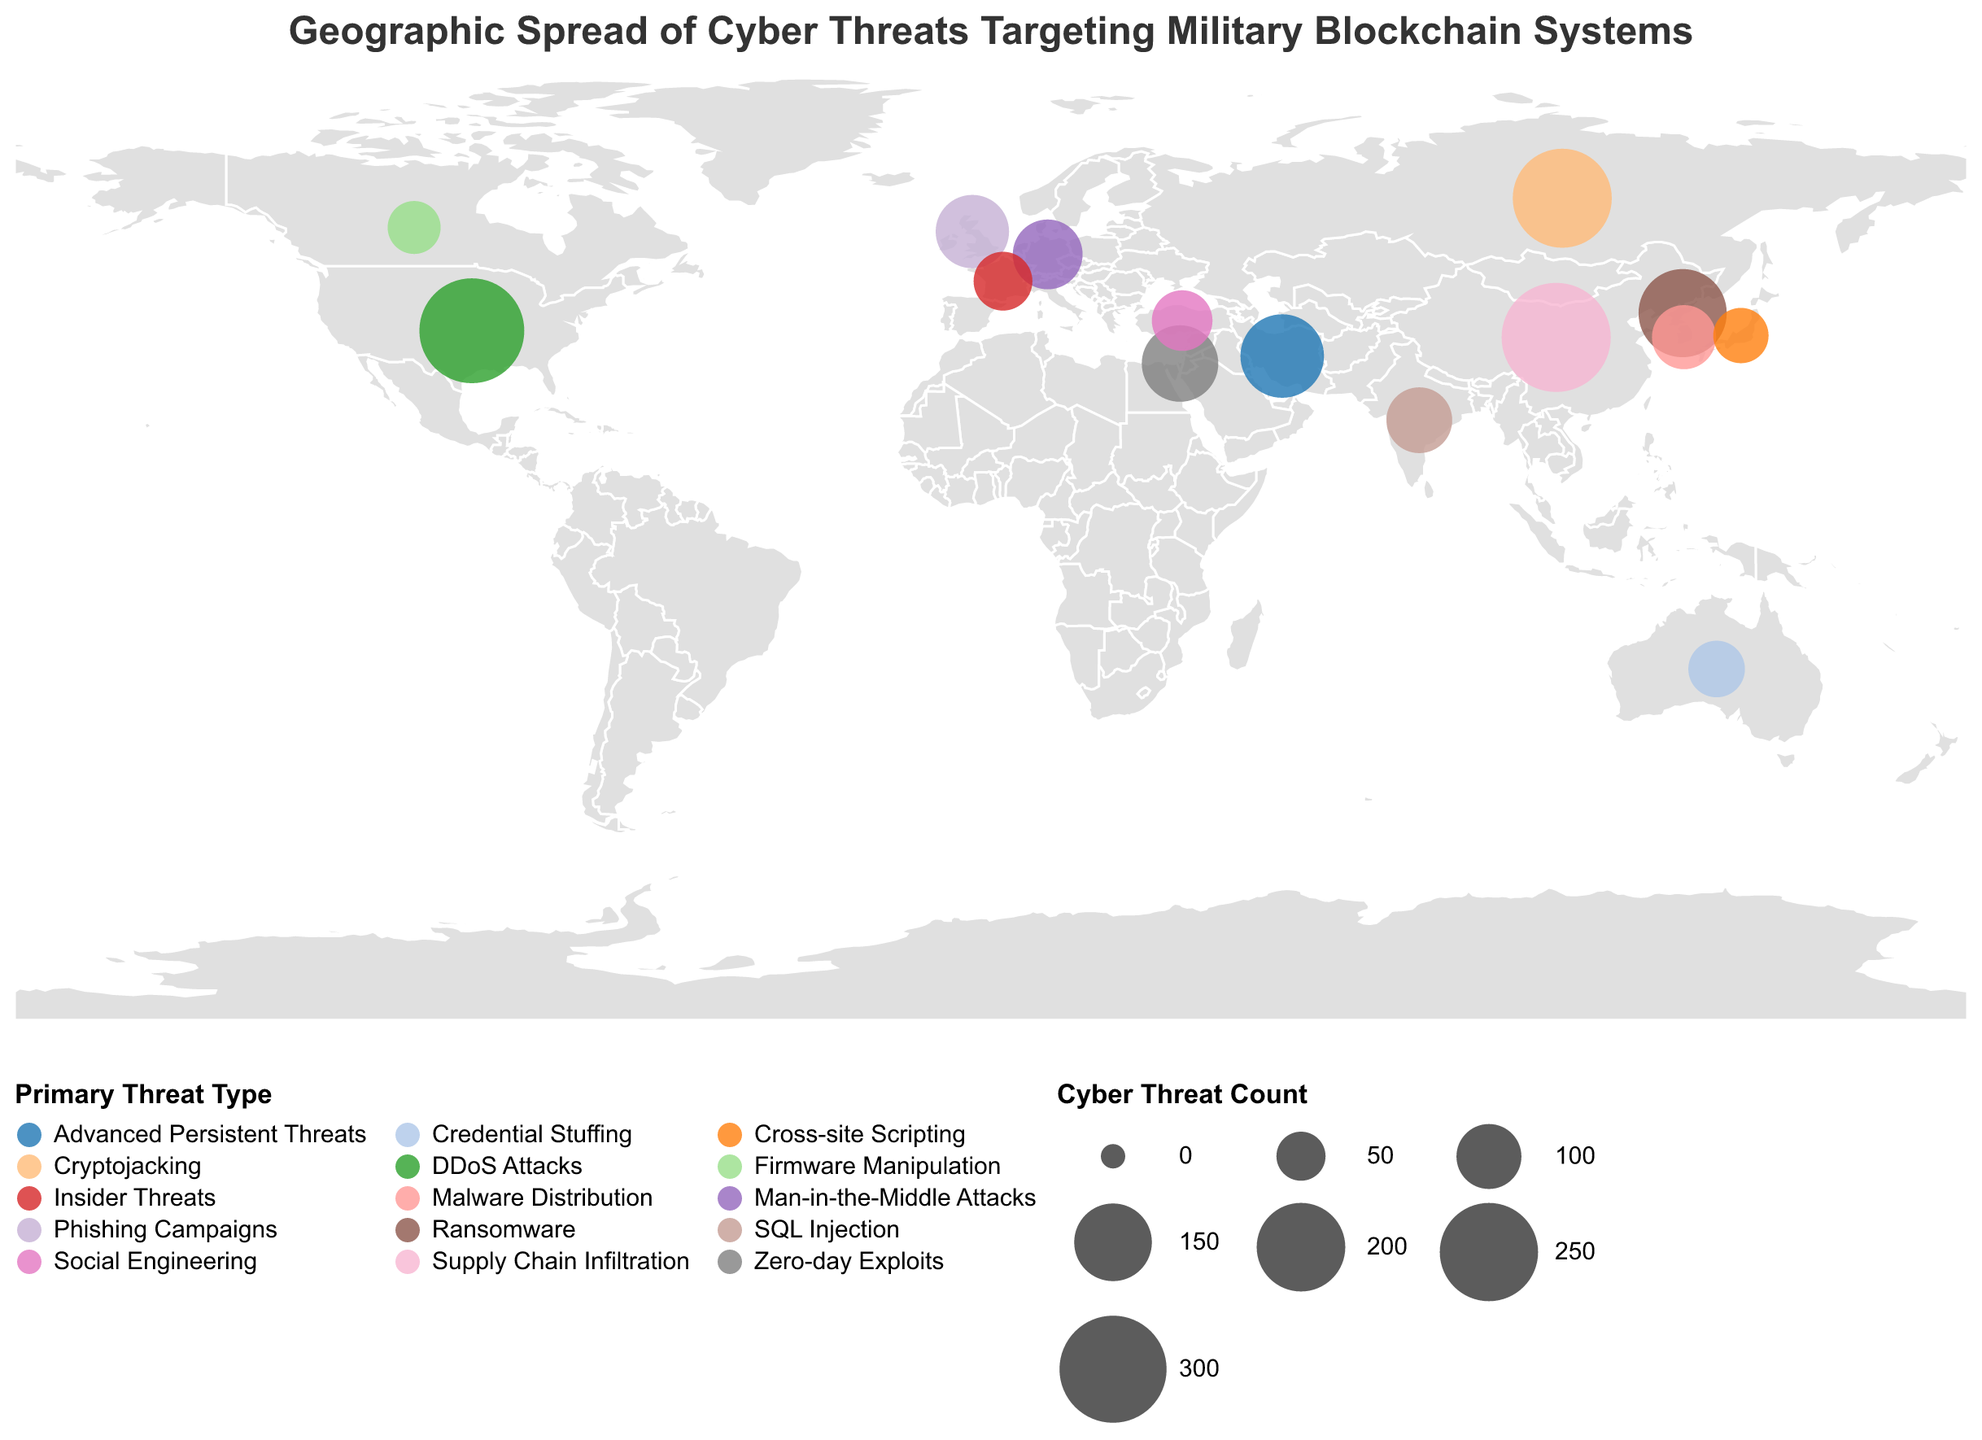what is the primary threat type with the highest cyber threat count? Check the data points and find the primary threat type with the highest count; China shows the highest count of 312 for Supply Chain Infiltration.
Answer: Supply Chain Infiltration Which country has the fewest cyber threats? Examine the data points to identify the country with the lowest cyber threat count; Canada has the fewest cyber threats with a count of 61.
Answer: Canada How many countries have a primary threat type of "Malware Distribution"? Check the data points and count how many entries have "Malware Distribution" as the Primary Threat Type; South Korea is the only country listed.
Answer: 1 What is the average cyber threat count across all listed countries? Sum the cyber threat counts of all countries and divide by the number of countries; (287+312+254+198+176+145+132+118+103+97+85+79+72+68+61)/15 = 162
Answer: 162 Which country in Europe has the highest cyber threat count? Identify the countries in Europe and compare their cyber threat counts; Russia has the highest with a count of 254.
Answer: Russia What is the total cyber threat count for countries in Asia? Sum the cyber threat counts of Asian countries (China, Russia, North Korea, Iran, India, South Korea, and Japan); 312+254+198+176+103+97+68 = 1208
Answer: 1208 Are there more countries with cyber threat counts above or below the median value? First, list the cyber threat counts in ascending order, find the median value, and then count how many countries are above and below it; median is 118. More countries are below the median (8) than above (7).
Answer: Below Which two countries have the same primary threat type but different threat counts? Look at the data points to find countries with the same primary threat type; Canada and Germany both have "Man-in-the-Middle Attacks" but different threat counts (118 vs. 61).
Answer: Canada and Germany What region in the world appears to be targeted primarily with "Cryptojacking"? Examine the primary threat type and associated data; "Cryptojacking" is primarily reported in Russia.
Answer: Russia 